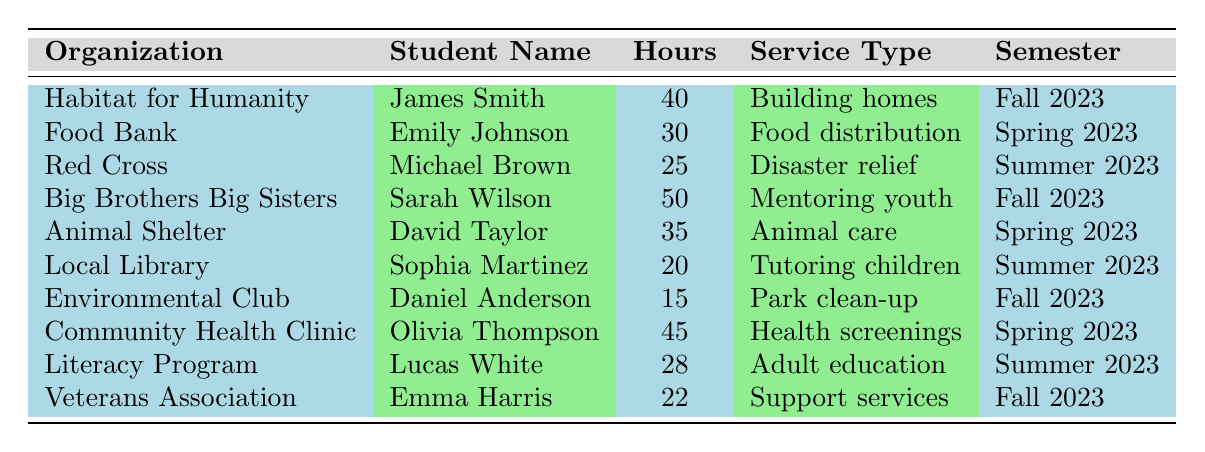What is the total number of volunteer hours contributed by the students in Fall 2023? From the table, the students who volunteered in Fall 2023 are James Smith (40 hours), Sarah Wilson (50 hours), Daniel Anderson (15 hours), and Emma Harris (22 hours). Adding these figures gives: 40 + 50 + 15 + 22 = 127 hours.
Answer: 127 Which student contributed the most volunteer hours? Looking at the "Hours" column, the highest value is 50 hours contributed by Sarah Wilson.
Answer: Sarah Wilson Did any student volunteer for more than 45 hours? The table shows Sarah Wilson (50 hours) and Olivia Thompson (45 hours), both of whom contributed more than 45 hours. Thus, the answer is yes.
Answer: Yes What type of service did Emily Johnson provide? By referring to the "Service Type" column for Emily Johnson’s row, she provided food distribution.
Answer: Food distribution How many students volunteered at the Animal Shelter? The table indicates that David Taylor is the only student listed under the Animal Shelter organization, so there is one student.
Answer: 1 What is the average number of volunteer hours across all organizations? To find the average, first sum the volunteer hours: 40 + 30 + 25 + 50 + 35 + 20 + 15 + 45 + 28 + 22 = 300 hours. Then, divide by the number of volunteers (10): 300/10 = 30 hours.
Answer: 30 Which organization had the least number of volunteer hours and how many hours were there? Scanning the table, the Environmental Club had the least hours with 15.
Answer: Environmental Club, 15 hours How many students volunteered in the Spring 2023 semester? The students who volunteered in Spring 2023 are Emily Johnson, David Taylor, and Olivia Thompson, totaling three students.
Answer: 3 Is there a student who volunteered for disaster relief? Yes, Michael Brown volunteered for disaster relief as indicated in the "Service Type" column.
Answer: Yes What is the total number of hours for organizations focused on health services? The two health service organizations here are the Community Health Clinic (45 hours) and the Red Cross (25 hours) which total: 45 + 25 = 70 hours.
Answer: 70 